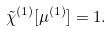<formula> <loc_0><loc_0><loc_500><loc_500>\tilde { \chi } ^ { ( 1 ) } [ \mu ^ { ( 1 ) } ] = 1 .</formula> 